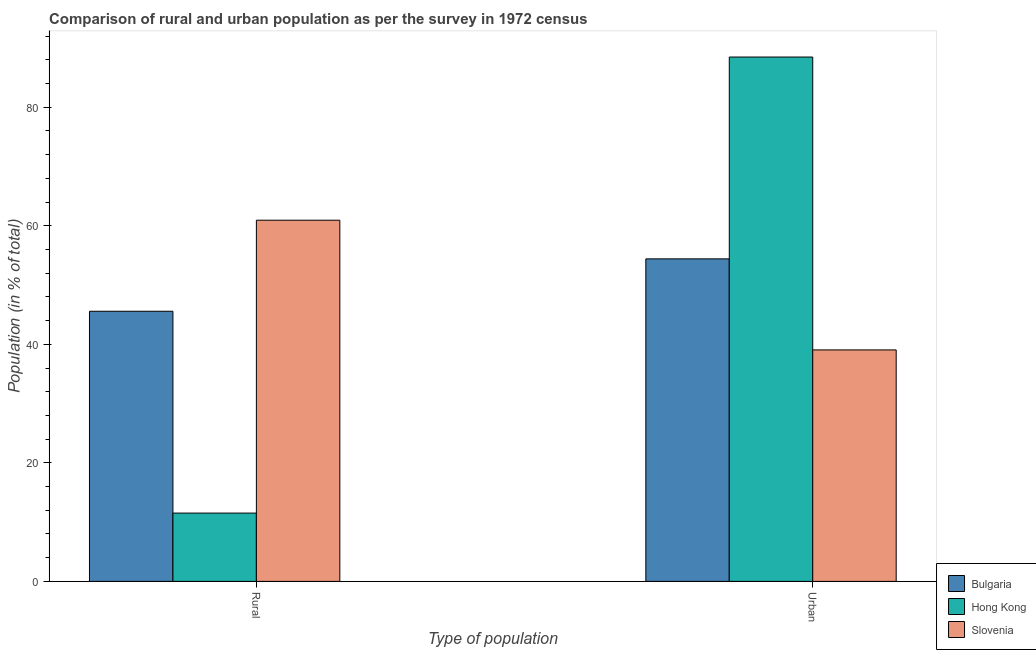Are the number of bars per tick equal to the number of legend labels?
Give a very brief answer. Yes. How many bars are there on the 2nd tick from the left?
Offer a terse response. 3. How many bars are there on the 2nd tick from the right?
Provide a succinct answer. 3. What is the label of the 1st group of bars from the left?
Offer a terse response. Rural. What is the urban population in Hong Kong?
Your answer should be very brief. 88.47. Across all countries, what is the maximum rural population?
Give a very brief answer. 60.94. Across all countries, what is the minimum rural population?
Offer a terse response. 11.53. In which country was the rural population maximum?
Offer a very short reply. Slovenia. In which country was the urban population minimum?
Keep it short and to the point. Slovenia. What is the total urban population in the graph?
Ensure brevity in your answer.  181.95. What is the difference between the rural population in Hong Kong and that in Bulgaria?
Offer a terse response. -34.06. What is the difference between the rural population in Bulgaria and the urban population in Hong Kong?
Make the answer very short. -42.89. What is the average rural population per country?
Ensure brevity in your answer.  39.35. What is the difference between the urban population and rural population in Bulgaria?
Make the answer very short. 8.84. What is the ratio of the rural population in Hong Kong to that in Bulgaria?
Keep it short and to the point. 0.25. Is the urban population in Hong Kong less than that in Bulgaria?
Your response must be concise. No. In how many countries, is the rural population greater than the average rural population taken over all countries?
Ensure brevity in your answer.  2. What does the 2nd bar from the left in Urban represents?
Offer a terse response. Hong Kong. What does the 2nd bar from the right in Rural represents?
Keep it short and to the point. Hong Kong. How many bars are there?
Offer a very short reply. 6. Does the graph contain grids?
Give a very brief answer. No. Where does the legend appear in the graph?
Your answer should be very brief. Bottom right. How are the legend labels stacked?
Offer a very short reply. Vertical. What is the title of the graph?
Your answer should be compact. Comparison of rural and urban population as per the survey in 1972 census. What is the label or title of the X-axis?
Offer a terse response. Type of population. What is the label or title of the Y-axis?
Provide a succinct answer. Population (in % of total). What is the Population (in % of total) in Bulgaria in Rural?
Keep it short and to the point. 45.58. What is the Population (in % of total) of Hong Kong in Rural?
Provide a short and direct response. 11.53. What is the Population (in % of total) in Slovenia in Rural?
Provide a succinct answer. 60.94. What is the Population (in % of total) of Bulgaria in Urban?
Keep it short and to the point. 54.42. What is the Population (in % of total) of Hong Kong in Urban?
Provide a short and direct response. 88.47. What is the Population (in % of total) of Slovenia in Urban?
Offer a terse response. 39.06. Across all Type of population, what is the maximum Population (in % of total) in Bulgaria?
Offer a very short reply. 54.42. Across all Type of population, what is the maximum Population (in % of total) in Hong Kong?
Make the answer very short. 88.47. Across all Type of population, what is the maximum Population (in % of total) in Slovenia?
Your response must be concise. 60.94. Across all Type of population, what is the minimum Population (in % of total) in Bulgaria?
Offer a very short reply. 45.58. Across all Type of population, what is the minimum Population (in % of total) in Hong Kong?
Offer a terse response. 11.53. Across all Type of population, what is the minimum Population (in % of total) in Slovenia?
Your response must be concise. 39.06. What is the total Population (in % of total) of Bulgaria in the graph?
Keep it short and to the point. 100. What is the total Population (in % of total) of Hong Kong in the graph?
Give a very brief answer. 100. What is the difference between the Population (in % of total) of Bulgaria in Rural and that in Urban?
Ensure brevity in your answer.  -8.84. What is the difference between the Population (in % of total) of Hong Kong in Rural and that in Urban?
Your answer should be compact. -76.95. What is the difference between the Population (in % of total) of Slovenia in Rural and that in Urban?
Your response must be concise. 21.88. What is the difference between the Population (in % of total) in Bulgaria in Rural and the Population (in % of total) in Hong Kong in Urban?
Ensure brevity in your answer.  -42.89. What is the difference between the Population (in % of total) of Bulgaria in Rural and the Population (in % of total) of Slovenia in Urban?
Ensure brevity in your answer.  6.52. What is the difference between the Population (in % of total) of Hong Kong in Rural and the Population (in % of total) of Slovenia in Urban?
Provide a short and direct response. -27.53. What is the average Population (in % of total) of Bulgaria per Type of population?
Make the answer very short. 50. What is the average Population (in % of total) in Slovenia per Type of population?
Offer a very short reply. 50. What is the difference between the Population (in % of total) in Bulgaria and Population (in % of total) in Hong Kong in Rural?
Provide a short and direct response. 34.05. What is the difference between the Population (in % of total) in Bulgaria and Population (in % of total) in Slovenia in Rural?
Give a very brief answer. -15.36. What is the difference between the Population (in % of total) in Hong Kong and Population (in % of total) in Slovenia in Rural?
Offer a terse response. -49.42. What is the difference between the Population (in % of total) of Bulgaria and Population (in % of total) of Hong Kong in Urban?
Your answer should be compact. -34.05. What is the difference between the Population (in % of total) of Bulgaria and Population (in % of total) of Slovenia in Urban?
Provide a succinct answer. 15.36. What is the difference between the Population (in % of total) of Hong Kong and Population (in % of total) of Slovenia in Urban?
Your answer should be compact. 49.42. What is the ratio of the Population (in % of total) in Bulgaria in Rural to that in Urban?
Make the answer very short. 0.84. What is the ratio of the Population (in % of total) of Hong Kong in Rural to that in Urban?
Ensure brevity in your answer.  0.13. What is the ratio of the Population (in % of total) in Slovenia in Rural to that in Urban?
Ensure brevity in your answer.  1.56. What is the difference between the highest and the second highest Population (in % of total) in Bulgaria?
Give a very brief answer. 8.84. What is the difference between the highest and the second highest Population (in % of total) in Hong Kong?
Provide a succinct answer. 76.95. What is the difference between the highest and the second highest Population (in % of total) in Slovenia?
Your answer should be compact. 21.88. What is the difference between the highest and the lowest Population (in % of total) in Bulgaria?
Offer a terse response. 8.84. What is the difference between the highest and the lowest Population (in % of total) in Hong Kong?
Keep it short and to the point. 76.95. What is the difference between the highest and the lowest Population (in % of total) of Slovenia?
Offer a very short reply. 21.88. 